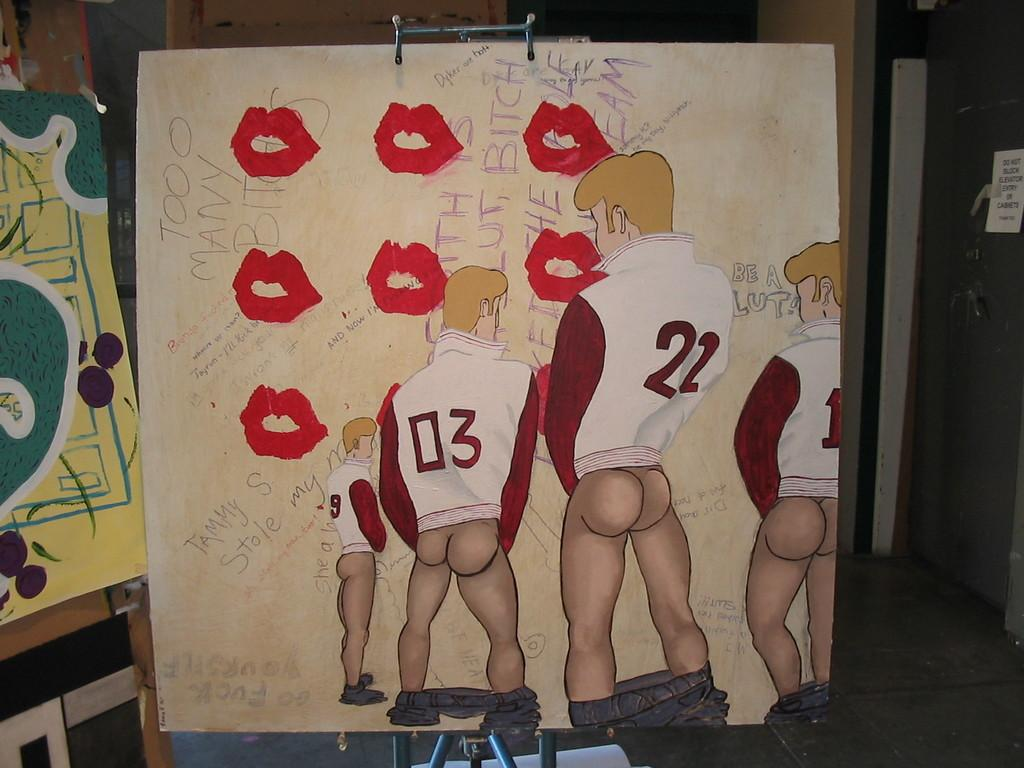What is the main subject in the center of the image? There is a poster in the center of the image. How many chickens are depicted on the poster in the image? There is no information about chickens on the poster in the image. What type of yoke is shown on the poster in the image? There is no yoke present on the poster in the image. 